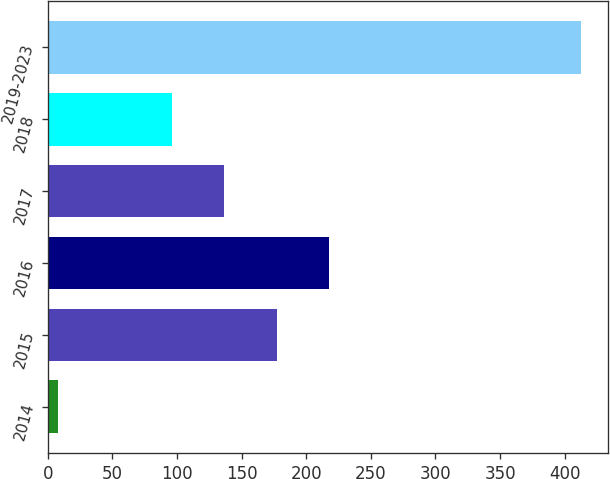Convert chart. <chart><loc_0><loc_0><loc_500><loc_500><bar_chart><fcel>2014<fcel>2015<fcel>2016<fcel>2017<fcel>2018<fcel>2019-2023<nl><fcel>8<fcel>177<fcel>217.5<fcel>136.5<fcel>96<fcel>413<nl></chart> 